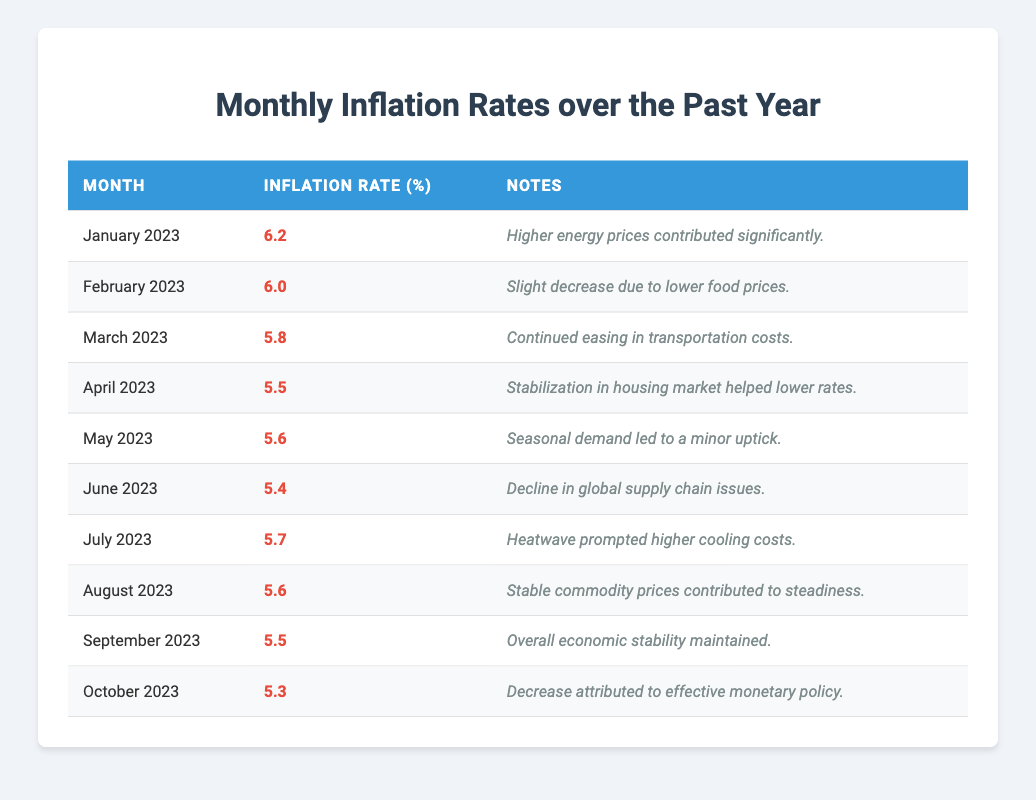What was the inflation rate in September 2023? The table indicates that the inflation rate for September 2023 is listed as 5.5%.
Answer: 5.5% Which month had the highest inflation rate over the past year? Referring to the table, January 2023 had the highest inflation rate at 6.2%.
Answer: January 2023 What was the average inflation rate over the last year? To find the average, sum the inflation rates across all months (6.2 + 6.0 + 5.8 + 5.5 + 5.6 + 5.4 + 5.7 + 5.6 + 5.5 + 5.3 = 56.6) and divide by the number of months (10). Thus, 56.6/10 = 5.66.
Answer: 5.66 Did the inflation rate decrease from May to June 2023? The inflation rate was 5.6% in May and decreased to 5.4% in June, indicating a decrease.
Answer: Yes Which month saw a minor uptick in inflation rates? The table notes that May 2023 saw a minor uptick with an inflation rate of 5.6%.
Answer: May 2023 By how much did the inflation rate drop from January to October 2023? The inflation rate in January was 6.2% and in October it dropped to 5.3%. The difference is 6.2 - 5.3 = 0.9%.
Answer: 0.9% What significant factor contributed to the decrease in inflation in October 2023? The table mentions that the decrease in October 2023 was attributed to effective monetary policy.
Answer: Effective monetary policy Was there a month where the inflation rate stayed the same as the previous month? Observing the table, there were no months where the inflation rate remained unchanged; rates were either increasing or decreasing each month.
Answer: No How many months had an inflation rate below 6%? The table shows inflation rates below 6% in March (5.8%), April (5.5%), June (5.4%), July (5.7%), August (5.6%), September (5.5%), and October (5.3%), totaling 7 months.
Answer: 7 months In which month did seasonal demand cause an uptick in inflation rates? Referring to the table, seasonal demand led to a minor uptick in inflation rates in May 2023.
Answer: May 2023 